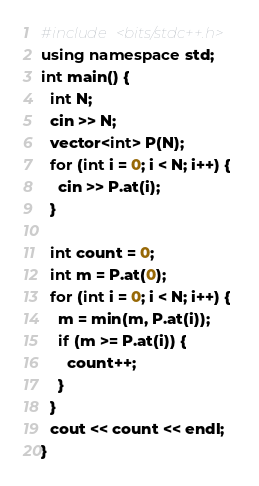<code> <loc_0><loc_0><loc_500><loc_500><_C++_>#include <bits/stdc++.h>
using namespace std;
int main() {
  int N;
  cin >> N;
  vector<int> P(N);
  for (int i = 0; i < N; i++) {
    cin >> P.at(i);
  }
  
  int count = 0;
  int m = P.at(0);
  for (int i = 0; i < N; i++) {
    m = min(m, P.at(i));
    if (m >= P.at(i)) {
      count++;
    }
  }
  cout << count << endl;
}</code> 